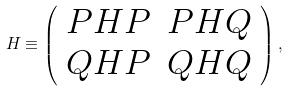<formula> <loc_0><loc_0><loc_500><loc_500>H \equiv \left ( \begin{array} { c c } P H P & P H Q \\ Q H P & Q H Q \end{array} \right ) ,</formula> 